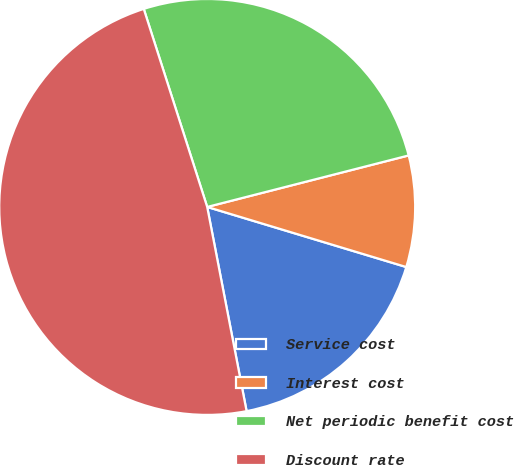Convert chart. <chart><loc_0><loc_0><loc_500><loc_500><pie_chart><fcel>Service cost<fcel>Interest cost<fcel>Net periodic benefit cost<fcel>Discount rate<nl><fcel>17.3%<fcel>8.65%<fcel>25.95%<fcel>48.1%<nl></chart> 